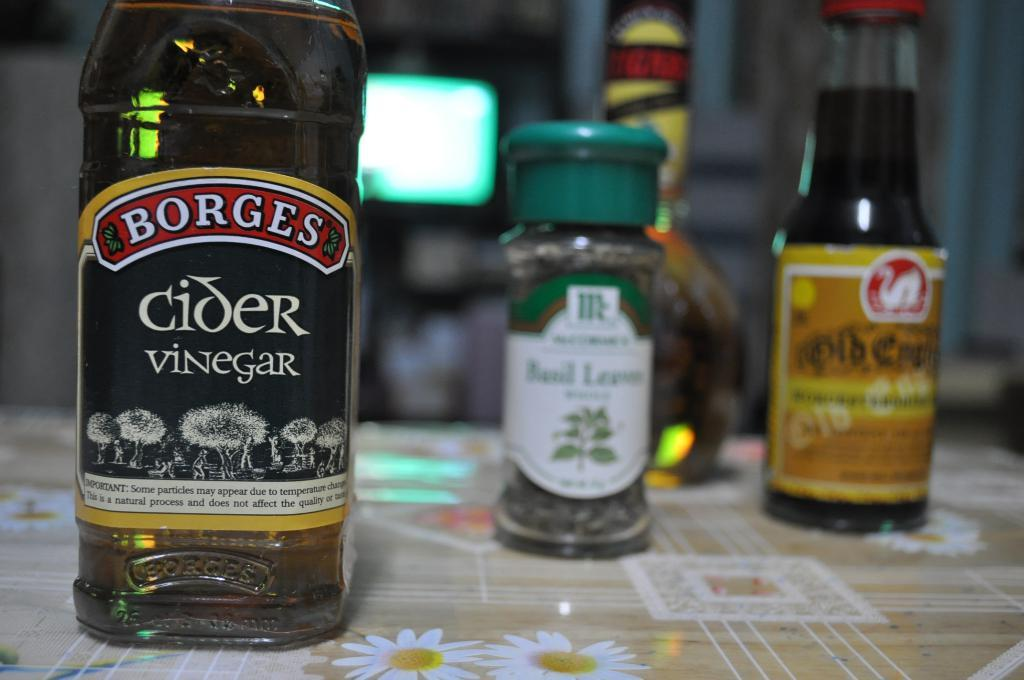<image>
Provide a brief description of the given image. Black bottle of Cider Vinegar on a table next to some other condiments. 